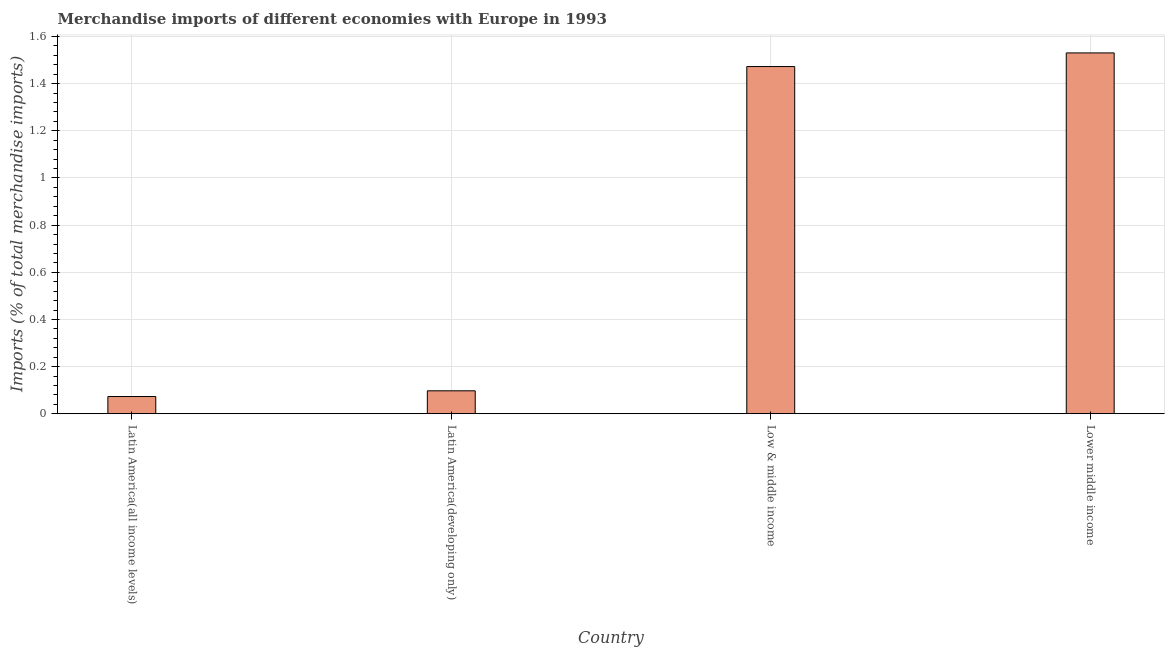Does the graph contain any zero values?
Make the answer very short. No. What is the title of the graph?
Keep it short and to the point. Merchandise imports of different economies with Europe in 1993. What is the label or title of the X-axis?
Provide a succinct answer. Country. What is the label or title of the Y-axis?
Give a very brief answer. Imports (% of total merchandise imports). What is the merchandise imports in Low & middle income?
Offer a very short reply. 1.47. Across all countries, what is the maximum merchandise imports?
Offer a very short reply. 1.53. Across all countries, what is the minimum merchandise imports?
Keep it short and to the point. 0.07. In which country was the merchandise imports maximum?
Give a very brief answer. Lower middle income. In which country was the merchandise imports minimum?
Give a very brief answer. Latin America(all income levels). What is the sum of the merchandise imports?
Your answer should be compact. 3.17. What is the difference between the merchandise imports in Low & middle income and Lower middle income?
Your response must be concise. -0.06. What is the average merchandise imports per country?
Your response must be concise. 0.79. What is the median merchandise imports?
Keep it short and to the point. 0.78. What is the ratio of the merchandise imports in Latin America(all income levels) to that in Latin America(developing only)?
Offer a terse response. 0.75. Is the difference between the merchandise imports in Latin America(developing only) and Lower middle income greater than the difference between any two countries?
Ensure brevity in your answer.  No. What is the difference between the highest and the second highest merchandise imports?
Offer a terse response. 0.06. Is the sum of the merchandise imports in Latin America(all income levels) and Latin America(developing only) greater than the maximum merchandise imports across all countries?
Your answer should be compact. No. What is the difference between the highest and the lowest merchandise imports?
Provide a short and direct response. 1.46. In how many countries, is the merchandise imports greater than the average merchandise imports taken over all countries?
Your answer should be compact. 2. How many bars are there?
Provide a short and direct response. 4. Are all the bars in the graph horizontal?
Make the answer very short. No. How many countries are there in the graph?
Provide a short and direct response. 4. What is the Imports (% of total merchandise imports) in Latin America(all income levels)?
Ensure brevity in your answer.  0.07. What is the Imports (% of total merchandise imports) of Latin America(developing only)?
Offer a terse response. 0.1. What is the Imports (% of total merchandise imports) of Low & middle income?
Offer a terse response. 1.47. What is the Imports (% of total merchandise imports) in Lower middle income?
Keep it short and to the point. 1.53. What is the difference between the Imports (% of total merchandise imports) in Latin America(all income levels) and Latin America(developing only)?
Your answer should be compact. -0.02. What is the difference between the Imports (% of total merchandise imports) in Latin America(all income levels) and Low & middle income?
Keep it short and to the point. -1.4. What is the difference between the Imports (% of total merchandise imports) in Latin America(all income levels) and Lower middle income?
Your answer should be compact. -1.46. What is the difference between the Imports (% of total merchandise imports) in Latin America(developing only) and Low & middle income?
Your answer should be compact. -1.38. What is the difference between the Imports (% of total merchandise imports) in Latin America(developing only) and Lower middle income?
Your answer should be very brief. -1.43. What is the difference between the Imports (% of total merchandise imports) in Low & middle income and Lower middle income?
Your response must be concise. -0.06. What is the ratio of the Imports (% of total merchandise imports) in Latin America(all income levels) to that in Latin America(developing only)?
Your answer should be very brief. 0.75. What is the ratio of the Imports (% of total merchandise imports) in Latin America(all income levels) to that in Lower middle income?
Your answer should be very brief. 0.05. What is the ratio of the Imports (% of total merchandise imports) in Latin America(developing only) to that in Low & middle income?
Keep it short and to the point. 0.07. What is the ratio of the Imports (% of total merchandise imports) in Latin America(developing only) to that in Lower middle income?
Ensure brevity in your answer.  0.06. What is the ratio of the Imports (% of total merchandise imports) in Low & middle income to that in Lower middle income?
Your answer should be compact. 0.96. 